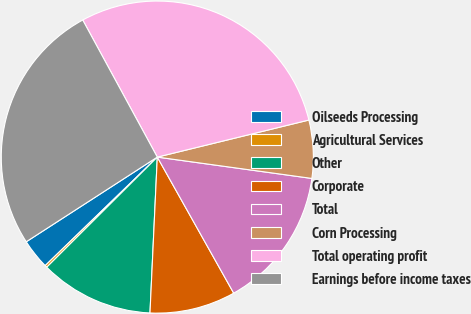<chart> <loc_0><loc_0><loc_500><loc_500><pie_chart><fcel>Oilseeds Processing<fcel>Agricultural Services<fcel>Other<fcel>Corporate<fcel>Total<fcel>Corn Processing<fcel>Total operating profit<fcel>Earnings before income taxes<nl><fcel>3.11%<fcel>0.23%<fcel>11.78%<fcel>8.89%<fcel>14.67%<fcel>6.0%<fcel>29.11%<fcel>26.2%<nl></chart> 